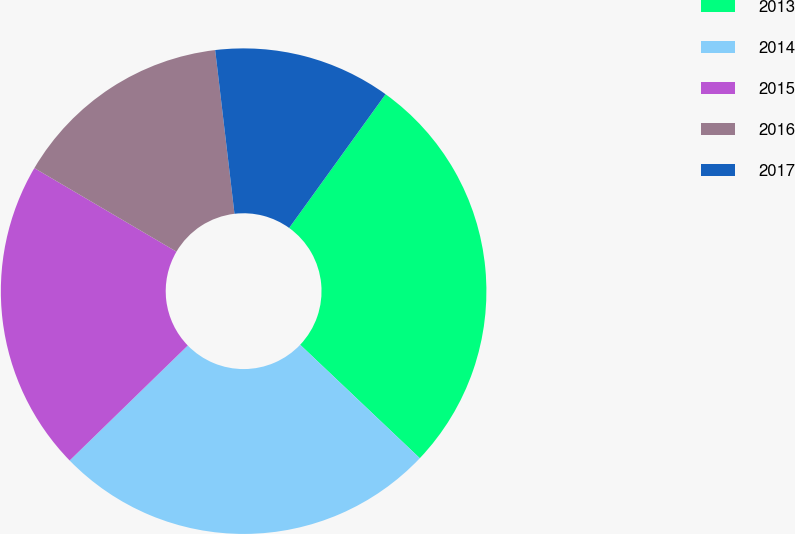<chart> <loc_0><loc_0><loc_500><loc_500><pie_chart><fcel>2013<fcel>2014<fcel>2015<fcel>2016<fcel>2017<nl><fcel>27.14%<fcel>25.64%<fcel>20.75%<fcel>14.67%<fcel>11.81%<nl></chart> 